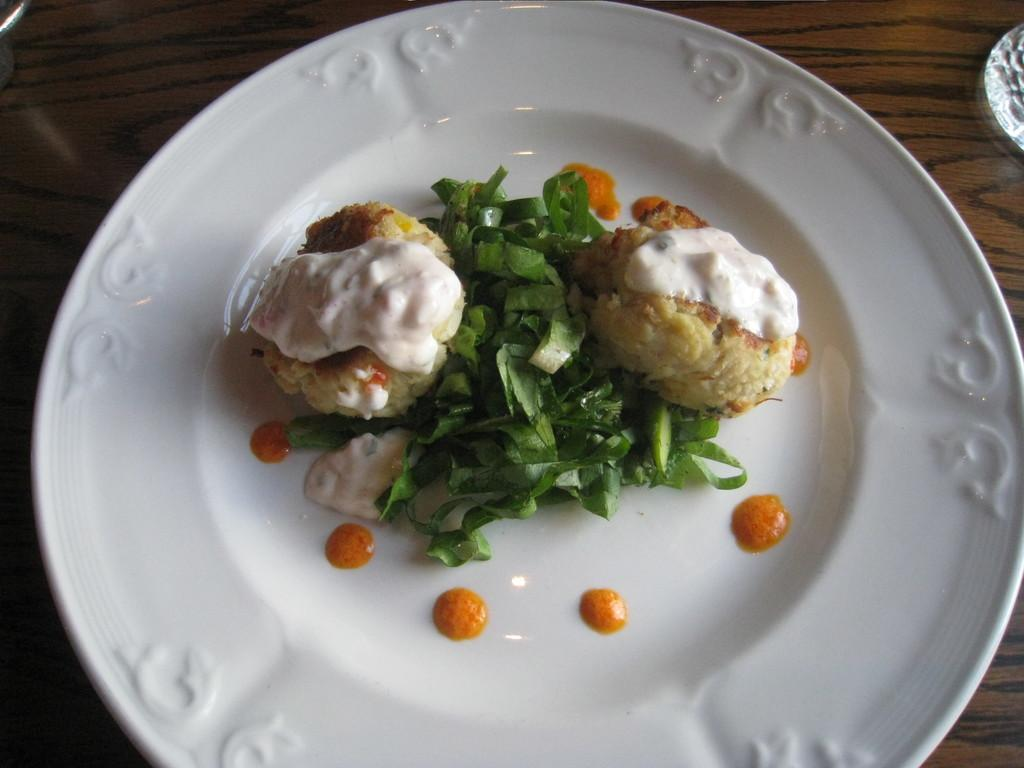What type of food can be seen in the image? There is cooked food in the image. What accompanies the cooked food? There are leaves served with the food. How is the food presented in the image? The food is served on a plate. What is the texture of the alley in the image? There is no alley present in the image, so it is not possible to determine its texture. 